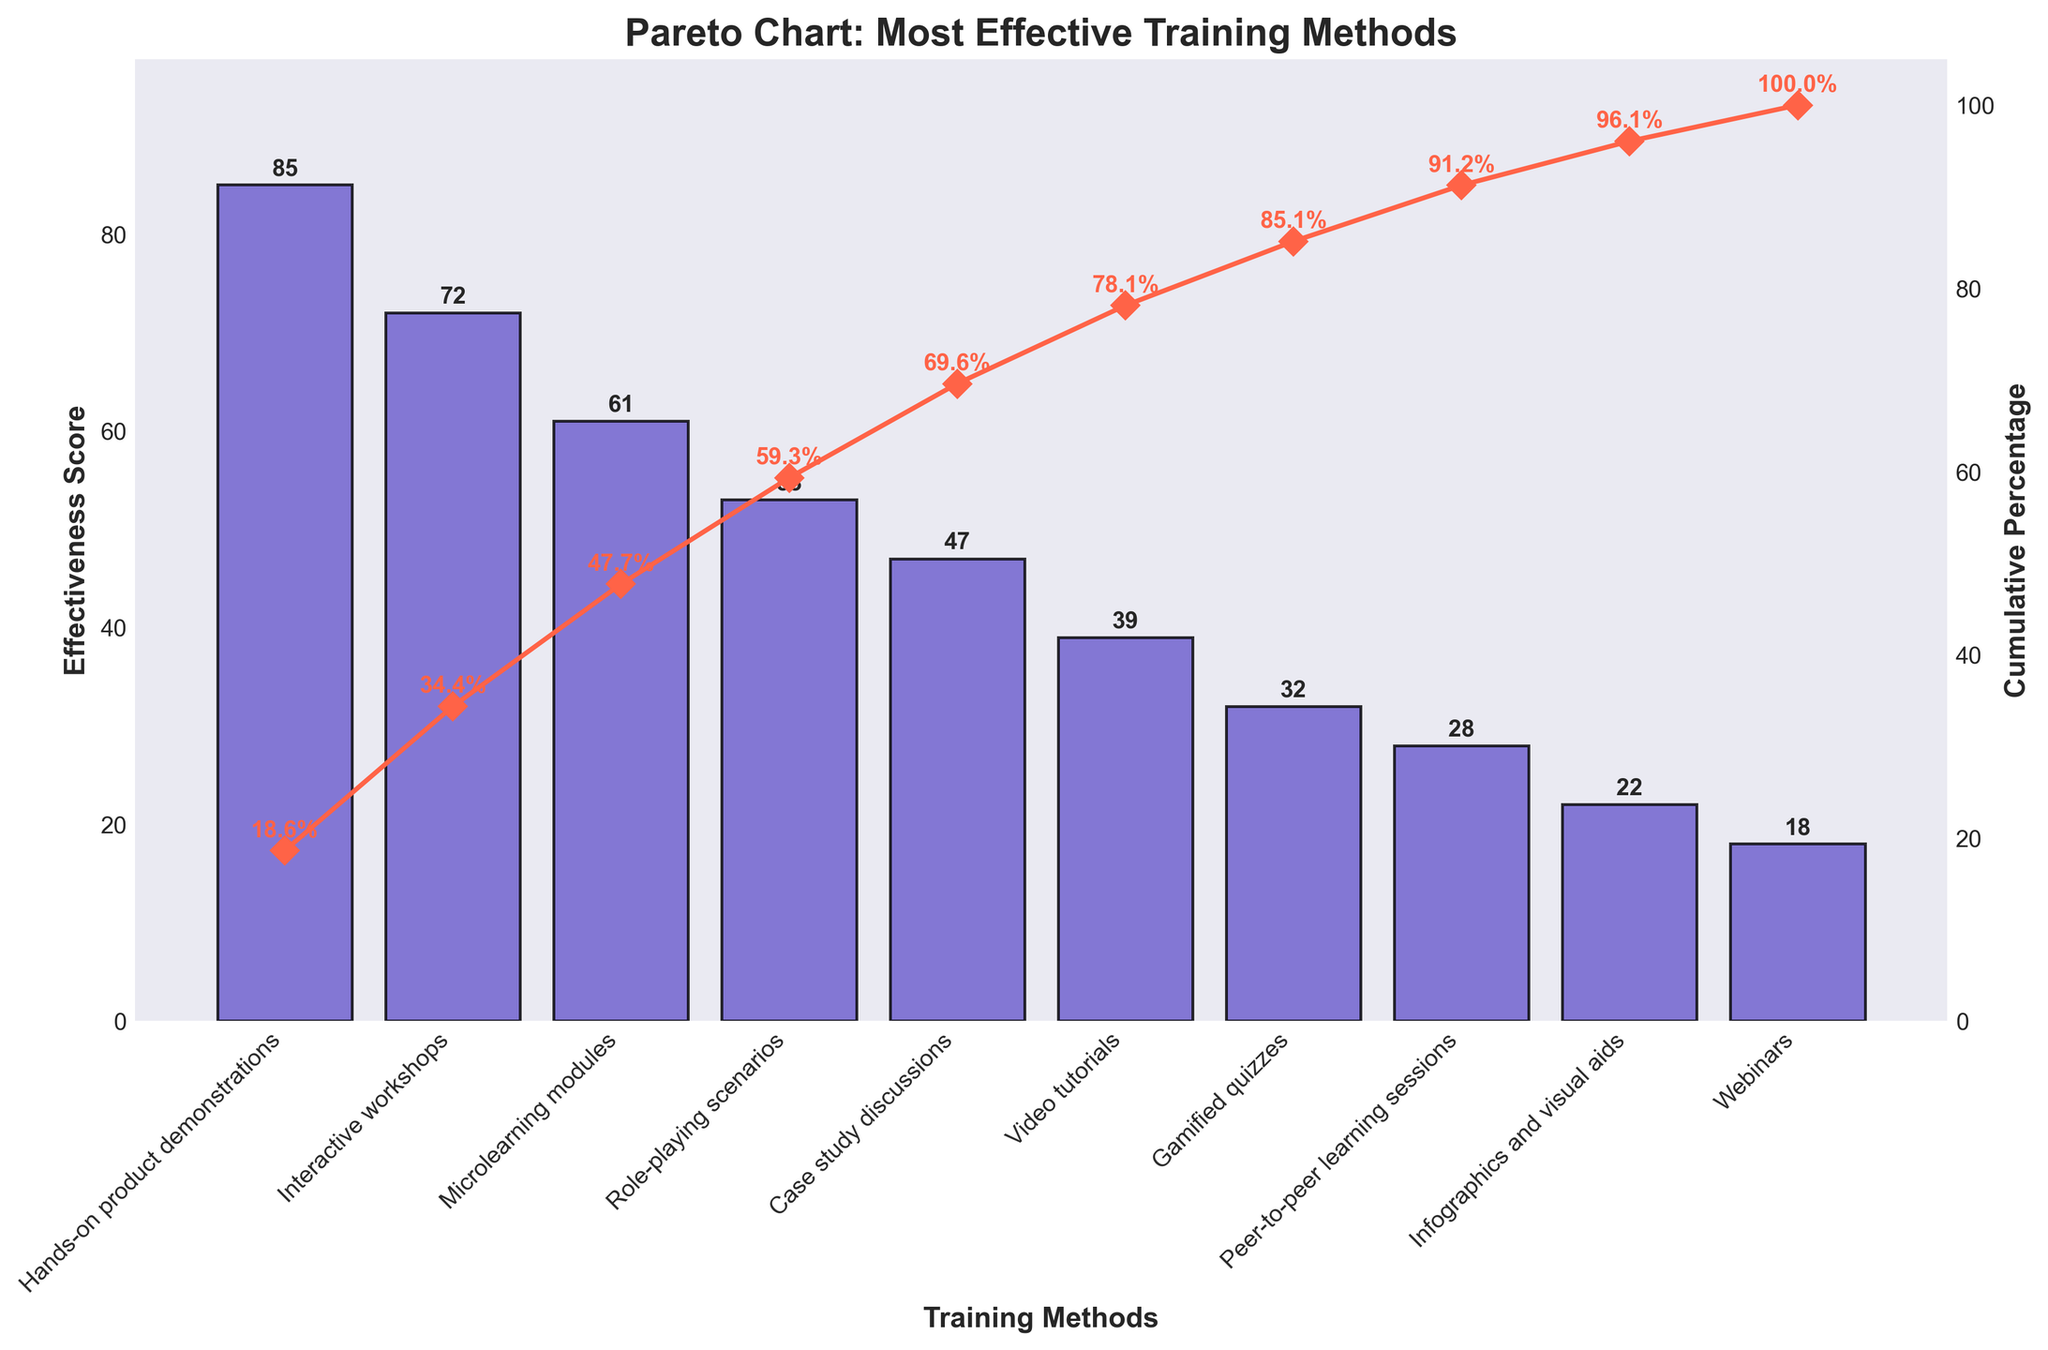What's the title of the figure? The title is written at the top center of the figure. The text should clearly describe the main focus of the chart.
Answer: Pareto Chart: Most Effective Training Methods How many training methods are shown in the figure? Each bar corresponds to a training method. By counting the bars, you can determine the number of training methods.
Answer: 10 Which training method has the highest effectiveness score? The method with the tallest bar in the figure has the highest effectiveness score. This is the first item on the x-axis.
Answer: Hands-on product demonstrations What is the effectiveness score for role-playing scenarios? Locate the bar labeled "Role-playing scenarios" and check the height of the bar. The numerical value of the height represents the effectiveness score.
Answer: 53 What is the cumulative percentage of effectiveness after the microlearning modules? Find the cumulative percentage curve and locate the point above the "Microlearning modules" bar. The value should be marked along the curve.
Answer: 72.0% How does the effectiveness score of video tutorials compare to that of interactive workshops? Locate the bars for both "Video tutorials" and "Interactive workshops" and compare their heights. The taller bar indicates a higher effectiveness score.
Answer: Interactive workshops is higher What is the effect on the cumulative percentage when adding the infographics and visual aids method? Find the cumulative percentage before and after the "Infographics and visual aids" bar, then calculate the difference between these percentages.
Answer: Increase by 5.2% Which methods together contribute to over 50% of the cumulative effectiveness score? Follow the cumulative percentage curve until it exceeds 50%. The bars corresponding to these methods represent them.
Answer: Hands-on product demonstrations, Interactive workshops, Microlearning modules Arrange the methods with effectiveness scores above 50 in descending order. From the tallest to the shortest bar above the effectiveness score of 50, list the respective training methods.
Answer: Hands-on product demonstrations, Interactive workshops, Microlearning modules, Role-playing scenarios What is the difference between the highest and lowest effectiveness scores shown in the figure? Identify the highest and lowest bars and subtract the value of the lowest effectiveness score from the highest.
Answer: 85 - 18 = 67 